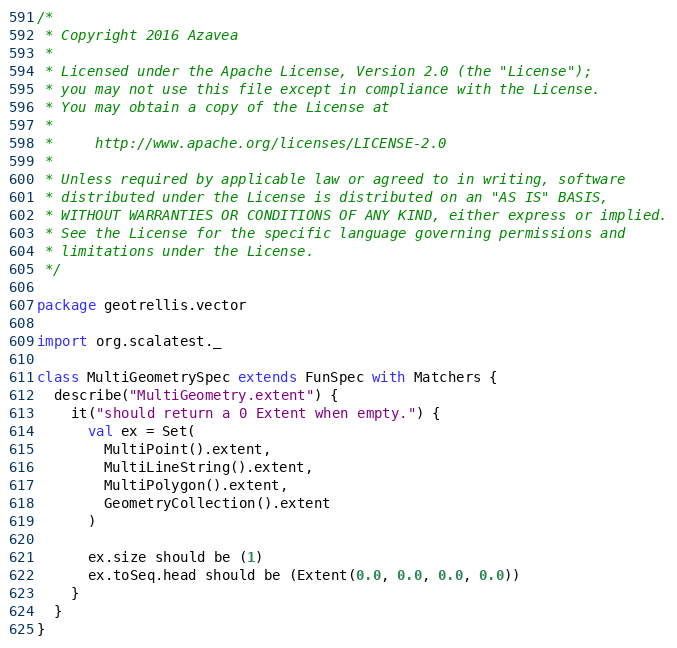Convert code to text. <code><loc_0><loc_0><loc_500><loc_500><_Scala_>/*
 * Copyright 2016 Azavea
 *
 * Licensed under the Apache License, Version 2.0 (the "License");
 * you may not use this file except in compliance with the License.
 * You may obtain a copy of the License at
 *
 *     http://www.apache.org/licenses/LICENSE-2.0
 *
 * Unless required by applicable law or agreed to in writing, software
 * distributed under the License is distributed on an "AS IS" BASIS,
 * WITHOUT WARRANTIES OR CONDITIONS OF ANY KIND, either express or implied.
 * See the License for the specific language governing permissions and
 * limitations under the License.
 */

package geotrellis.vector

import org.scalatest._

class MultiGeometrySpec extends FunSpec with Matchers {
  describe("MultiGeometry.extent") {
    it("should return a 0 Extent when empty.") {
      val ex = Set(
        MultiPoint().extent,
        MultiLineString().extent,
        MultiPolygon().extent,
        GeometryCollection().extent
      )

      ex.size should be (1)
      ex.toSeq.head should be (Extent(0.0, 0.0, 0.0, 0.0))
    }
  }
}
</code> 